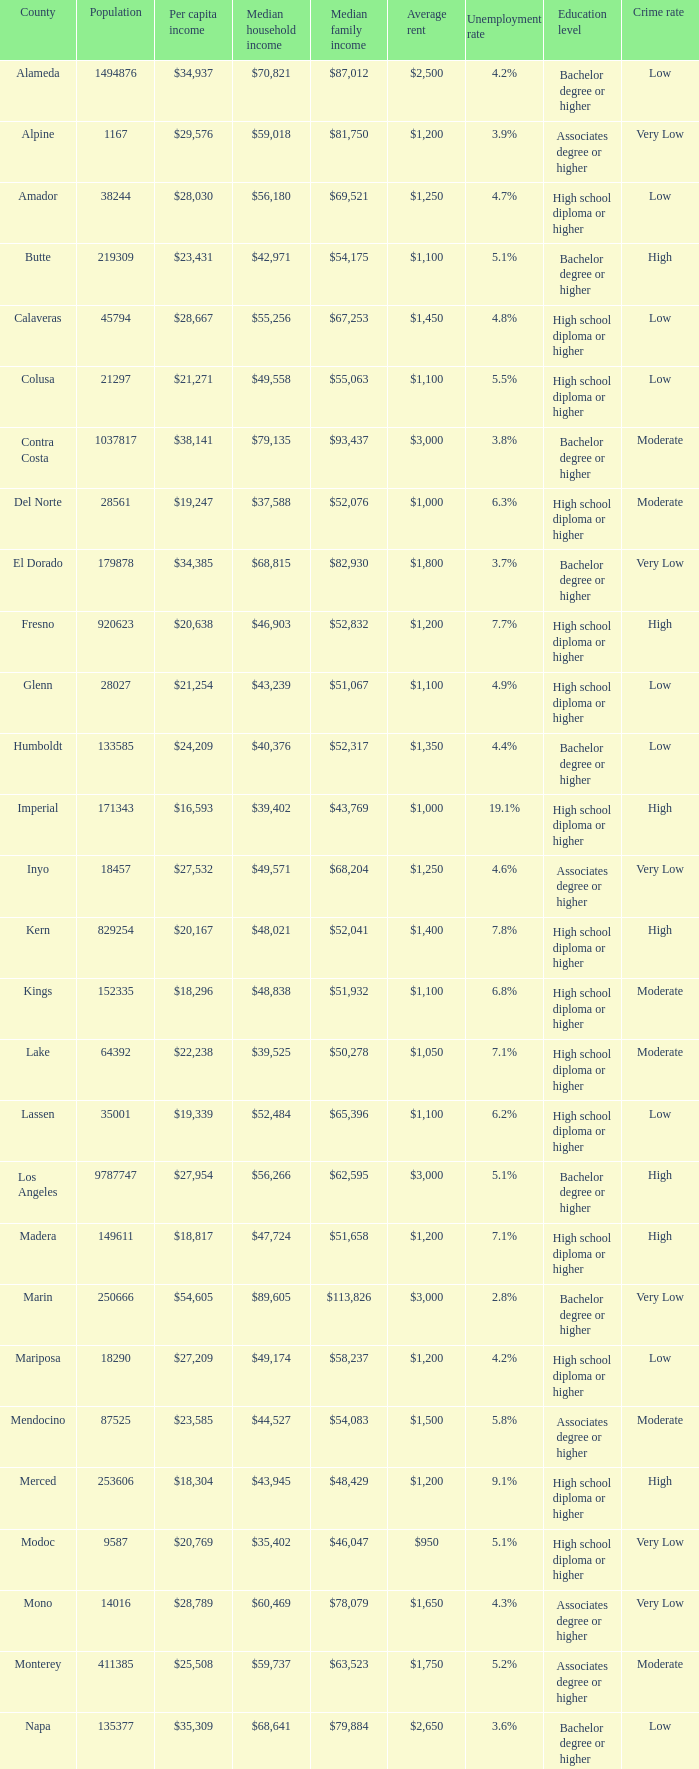What is the median household income in riverside? $65,457. 